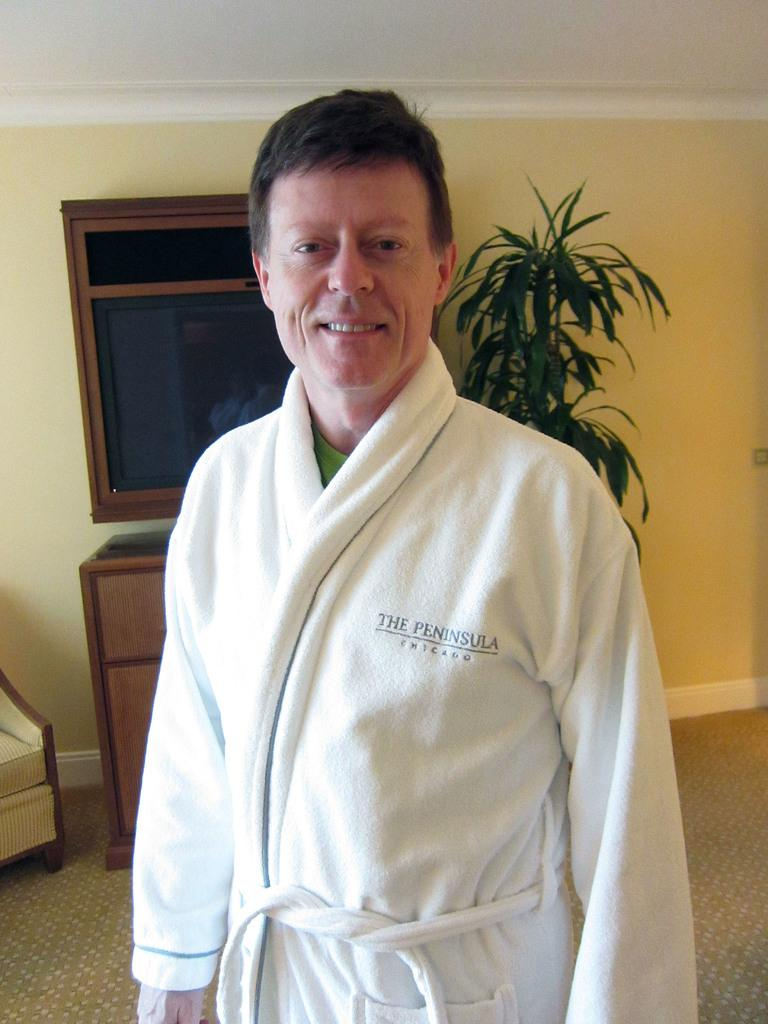<image>
Render a clear and concise summary of the photo. A man poses for a photo while wearing a white bath robe from The Peninsula in Chicago. 